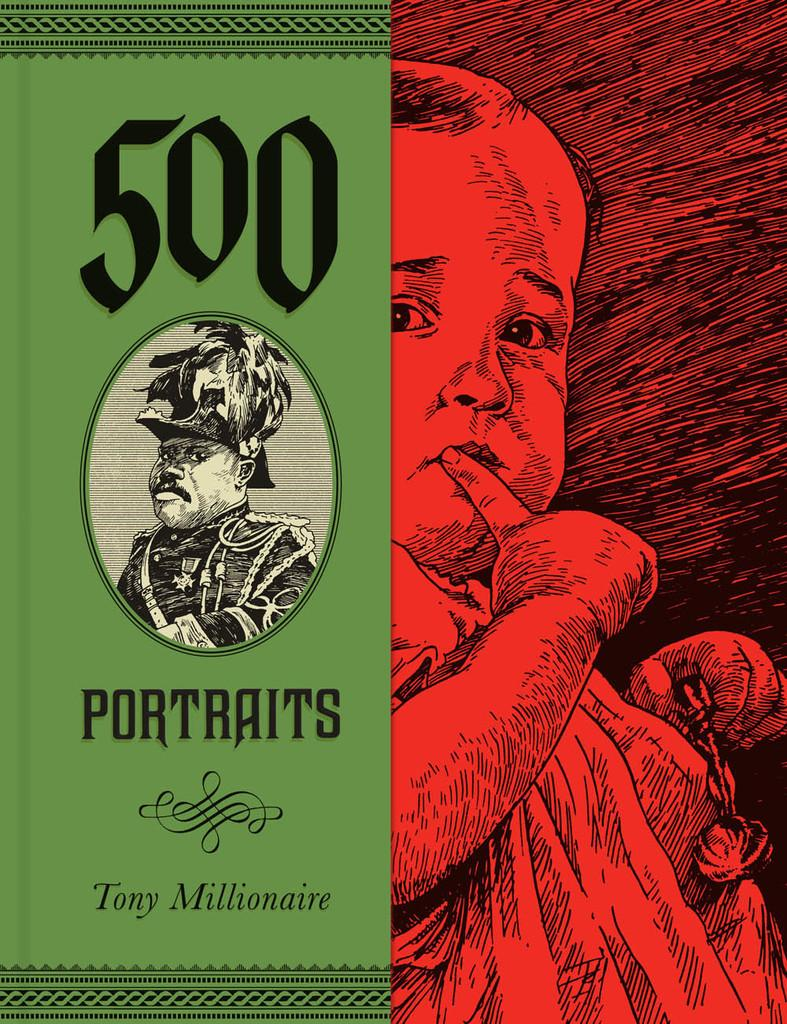What type of visual is the image? The image is a poster. What subjects are depicted on the poster? There is a baby and a man depicted on the poster. Is there any text present on the poster? Yes, there is text written on the poster. How many legs does the vegetable have in the image? There is no vegetable present in the image, so it is not possible to determine the number of legs it might have. 